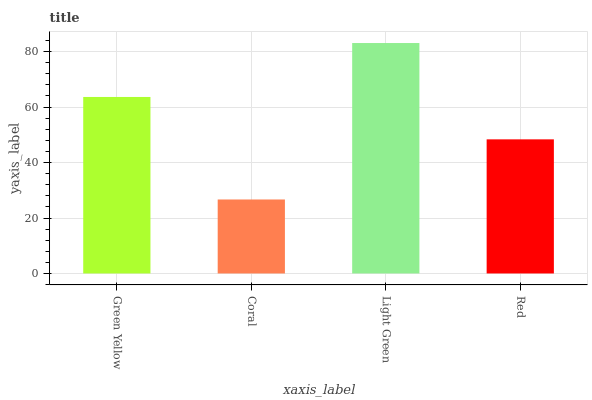Is Coral the minimum?
Answer yes or no. Yes. Is Light Green the maximum?
Answer yes or no. Yes. Is Light Green the minimum?
Answer yes or no. No. Is Coral the maximum?
Answer yes or no. No. Is Light Green greater than Coral?
Answer yes or no. Yes. Is Coral less than Light Green?
Answer yes or no. Yes. Is Coral greater than Light Green?
Answer yes or no. No. Is Light Green less than Coral?
Answer yes or no. No. Is Green Yellow the high median?
Answer yes or no. Yes. Is Red the low median?
Answer yes or no. Yes. Is Light Green the high median?
Answer yes or no. No. Is Light Green the low median?
Answer yes or no. No. 